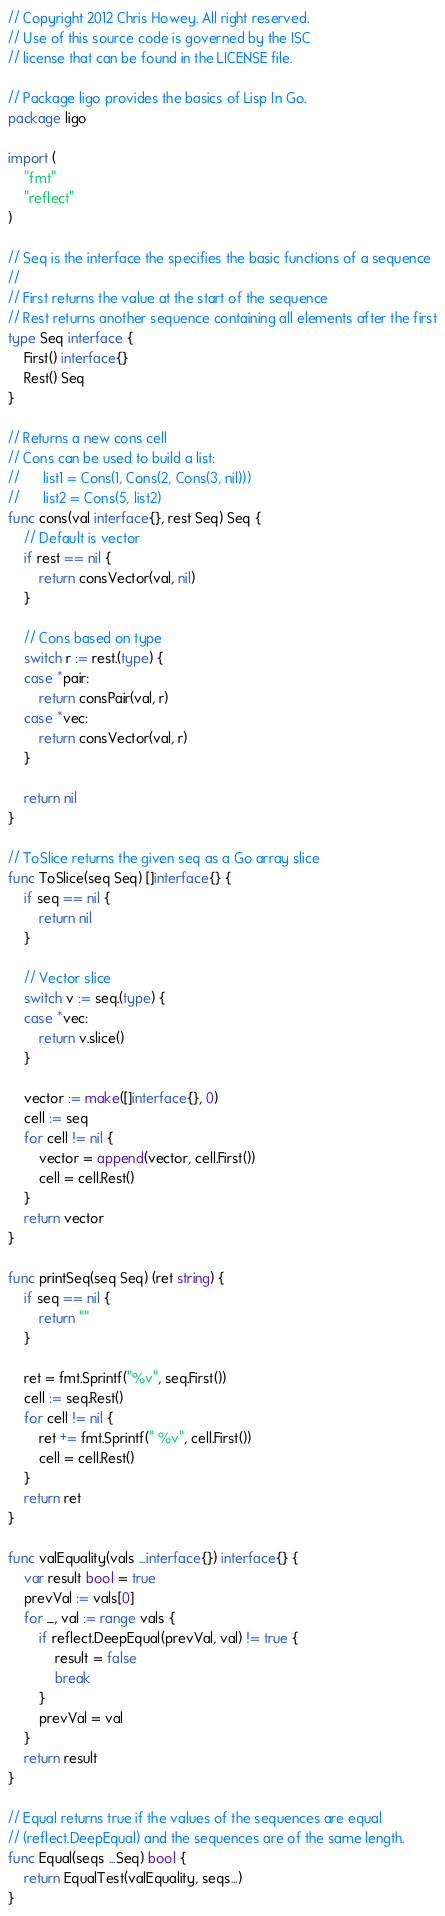<code> <loc_0><loc_0><loc_500><loc_500><_Go_>// Copyright 2012 Chris Howey. All right reserved.
// Use of this source code is governed by the ISC
// license that can be found in the LICENSE file.

// Package ligo provides the basics of Lisp In Go.
package ligo

import (
	"fmt"
	"reflect"
)

// Seq is the interface the specifies the basic functions of a sequence
//
// First returns the value at the start of the sequence
// Rest returns another sequence containing all elements after the first
type Seq interface {
	First() interface{}
	Rest() Seq
}

// Returns a new cons cell
// Cons can be used to build a list:
//      list1 = Cons(1, Cons(2, Cons(3, nil)))
//      list2 = Cons(5, list2)
func cons(val interface{}, rest Seq) Seq {
	// Default is vector
	if rest == nil {
		return consVector(val, nil)
	}

	// Cons based on type
	switch r := rest.(type) {
	case *pair:
		return consPair(val, r)
	case *vec:
		return consVector(val, r)
	}

	return nil
}

// ToSlice returns the given seq as a Go array slice
func ToSlice(seq Seq) []interface{} {
	if seq == nil {
		return nil
	}

	// Vector slice
	switch v := seq.(type) {
	case *vec:
		return v.slice()
	}

	vector := make([]interface{}, 0)
	cell := seq
	for cell != nil {
		vector = append(vector, cell.First())
		cell = cell.Rest()
	}
	return vector
}

func printSeq(seq Seq) (ret string) {
	if seq == nil {
		return ""
	}

	ret = fmt.Sprintf("%v", seq.First())
	cell := seq.Rest()
	for cell != nil {
		ret += fmt.Sprintf(" %v", cell.First())
		cell = cell.Rest()
	}
	return ret
}

func valEquality(vals ...interface{}) interface{} {
	var result bool = true
	prevVal := vals[0]
	for _, val := range vals {
		if reflect.DeepEqual(prevVal, val) != true {
			result = false
			break
		}
		prevVal = val
	}
	return result
}

// Equal returns true if the values of the sequences are equal
// (reflect.DeepEqual) and the sequences are of the same length.
func Equal(seqs ...Seq) bool {
	return EqualTest(valEquality, seqs...)
}
</code> 